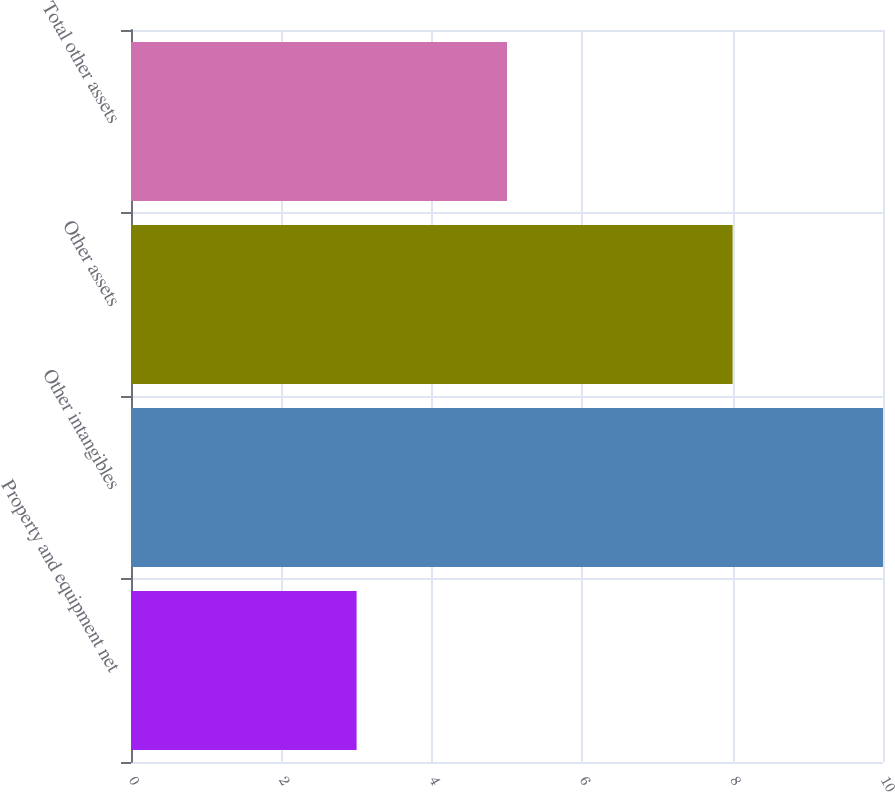Convert chart to OTSL. <chart><loc_0><loc_0><loc_500><loc_500><bar_chart><fcel>Property and equipment net<fcel>Other intangibles<fcel>Other assets<fcel>Total other assets<nl><fcel>3<fcel>10<fcel>8<fcel>5<nl></chart> 